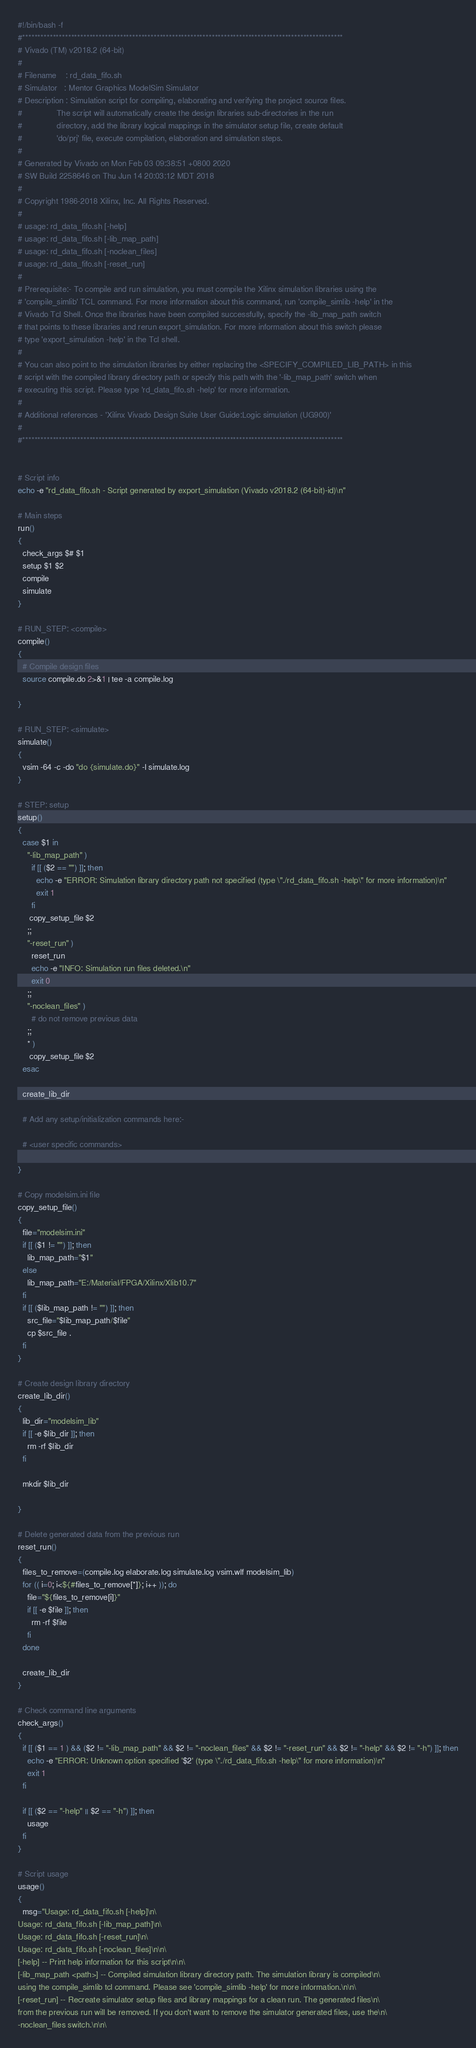<code> <loc_0><loc_0><loc_500><loc_500><_Bash_>#!/bin/bash -f
#*********************************************************************************************************
# Vivado (TM) v2018.2 (64-bit)
#
# Filename    : rd_data_fifo.sh
# Simulator   : Mentor Graphics ModelSim Simulator
# Description : Simulation script for compiling, elaborating and verifying the project source files.
#               The script will automatically create the design libraries sub-directories in the run
#               directory, add the library logical mappings in the simulator setup file, create default
#               'do/prj' file, execute compilation, elaboration and simulation steps.
#
# Generated by Vivado on Mon Feb 03 09:38:51 +0800 2020
# SW Build 2258646 on Thu Jun 14 20:03:12 MDT 2018
#
# Copyright 1986-2018 Xilinx, Inc. All Rights Reserved. 
#
# usage: rd_data_fifo.sh [-help]
# usage: rd_data_fifo.sh [-lib_map_path]
# usage: rd_data_fifo.sh [-noclean_files]
# usage: rd_data_fifo.sh [-reset_run]
#
# Prerequisite:- To compile and run simulation, you must compile the Xilinx simulation libraries using the
# 'compile_simlib' TCL command. For more information about this command, run 'compile_simlib -help' in the
# Vivado Tcl Shell. Once the libraries have been compiled successfully, specify the -lib_map_path switch
# that points to these libraries and rerun export_simulation. For more information about this switch please
# type 'export_simulation -help' in the Tcl shell.
#
# You can also point to the simulation libraries by either replacing the <SPECIFY_COMPILED_LIB_PATH> in this
# script with the compiled library directory path or specify this path with the '-lib_map_path' switch when
# executing this script. Please type 'rd_data_fifo.sh -help' for more information.
#
# Additional references - 'Xilinx Vivado Design Suite User Guide:Logic simulation (UG900)'
#
#*********************************************************************************************************


# Script info
echo -e "rd_data_fifo.sh - Script generated by export_simulation (Vivado v2018.2 (64-bit)-id)\n"

# Main steps
run()
{
  check_args $# $1
  setup $1 $2
  compile
  simulate
}

# RUN_STEP: <compile>
compile()
{
  # Compile design files
  source compile.do 2>&1 | tee -a compile.log

}

# RUN_STEP: <simulate>
simulate()
{
  vsim -64 -c -do "do {simulate.do}" -l simulate.log
}

# STEP: setup
setup()
{
  case $1 in
    "-lib_map_path" )
      if [[ ($2 == "") ]]; then
        echo -e "ERROR: Simulation library directory path not specified (type \"./rd_data_fifo.sh -help\" for more information)\n"
        exit 1
      fi
     copy_setup_file $2
    ;;
    "-reset_run" )
      reset_run
      echo -e "INFO: Simulation run files deleted.\n"
      exit 0
    ;;
    "-noclean_files" )
      # do not remove previous data
    ;;
    * )
     copy_setup_file $2
  esac

  create_lib_dir

  # Add any setup/initialization commands here:-

  # <user specific commands>

}

# Copy modelsim.ini file
copy_setup_file()
{
  file="modelsim.ini"
  if [[ ($1 != "") ]]; then
    lib_map_path="$1"
  else
    lib_map_path="E:/Material/FPGA/Xilinx/Xlib10.7"
  fi
  if [[ ($lib_map_path != "") ]]; then
    src_file="$lib_map_path/$file"
    cp $src_file .
  fi
}

# Create design library directory
create_lib_dir()
{
  lib_dir="modelsim_lib"
  if [[ -e $lib_dir ]]; then
    rm -rf $lib_dir
  fi

  mkdir $lib_dir

}

# Delete generated data from the previous run
reset_run()
{
  files_to_remove=(compile.log elaborate.log simulate.log vsim.wlf modelsim_lib)
  for (( i=0; i<${#files_to_remove[*]}; i++ )); do
    file="${files_to_remove[i]}"
    if [[ -e $file ]]; then
      rm -rf $file
    fi
  done

  create_lib_dir
}

# Check command line arguments
check_args()
{
  if [[ ($1 == 1 ) && ($2 != "-lib_map_path" && $2 != "-noclean_files" && $2 != "-reset_run" && $2 != "-help" && $2 != "-h") ]]; then
    echo -e "ERROR: Unknown option specified '$2' (type \"./rd_data_fifo.sh -help\" for more information)\n"
    exit 1
  fi

  if [[ ($2 == "-help" || $2 == "-h") ]]; then
    usage
  fi
}

# Script usage
usage()
{
  msg="Usage: rd_data_fifo.sh [-help]\n\
Usage: rd_data_fifo.sh [-lib_map_path]\n\
Usage: rd_data_fifo.sh [-reset_run]\n\
Usage: rd_data_fifo.sh [-noclean_files]\n\n\
[-help] -- Print help information for this script\n\n\
[-lib_map_path <path>] -- Compiled simulation library directory path. The simulation library is compiled\n\
using the compile_simlib tcl command. Please see 'compile_simlib -help' for more information.\n\n\
[-reset_run] -- Recreate simulator setup files and library mappings for a clean run. The generated files\n\
from the previous run will be removed. If you don't want to remove the simulator generated files, use the\n\
-noclean_files switch.\n\n\</code> 